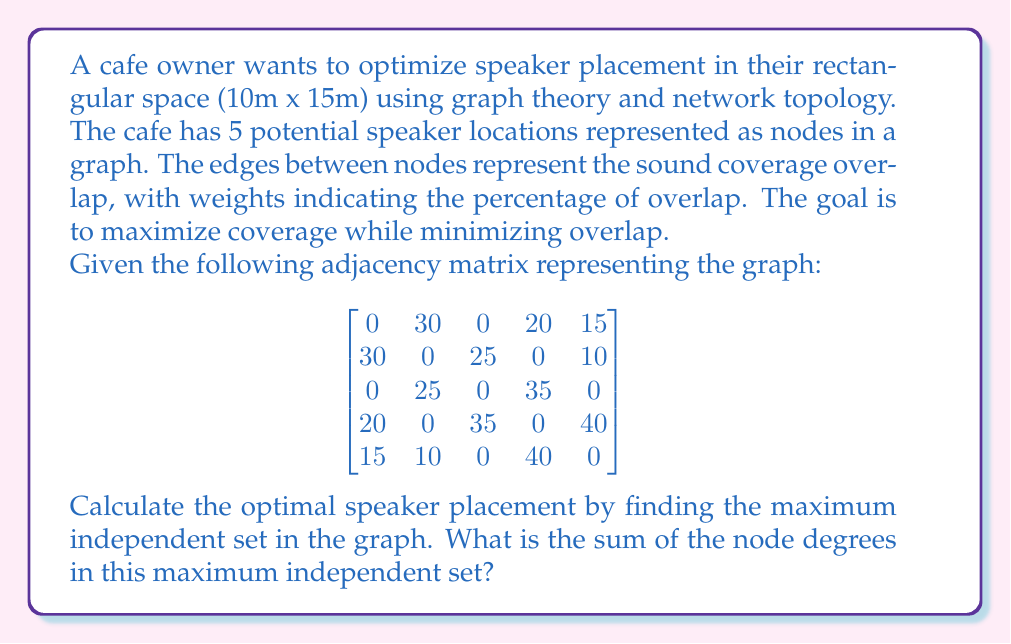Give your solution to this math problem. To solve this problem, we'll follow these steps:

1) First, we need to convert the adjacency matrix into a graph. Each non-zero entry represents an edge between nodes.

2) We're looking for the maximum independent set - a set of nodes where no two nodes are adjacent. This will give us the optimal speaker placement with minimal overlap.

3) For this graph, we can visually determine the maximum independent set:
   - Nodes 1 and 3 form an independent set
   - Nodes 2 and 4 form another independent set
   - Node 5 can't be added to either set without creating an adjacency

   Therefore, the maximum independent set is {1, 3}.

4) Now, we need to calculate the sum of the degrees of these nodes in the original graph.

5) To find the degree of a node, we sum its row (or column) in the adjacency matrix:
   - For node 1: 30 + 20 + 15 = 65
   - For node 3: 25 + 35 = 60

6) The sum of these degrees is 65 + 60 = 125

Therefore, the sum of the node degrees in the maximum independent set is 125.

[asy]
unitsize(30);
pair[] A = {(0,0), (2,0), (1,1.7), (-1,1), (3,1)};
for(int i=0; i<5; ++i) {
  dot(A[i]);
  label("" + (i+1), A[i], N);
}
draw(A[0]--A[1]);
draw(A[0]--A[3]);
draw(A[0]--A[4]);
draw(A[1]--A[2]);
draw(A[1]--A[4]);
draw(A[2]--A[3]);
draw(A[3]--A[4]);
[/asy]
Answer: 125 